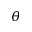<formula> <loc_0><loc_0><loc_500><loc_500>\theta</formula> 